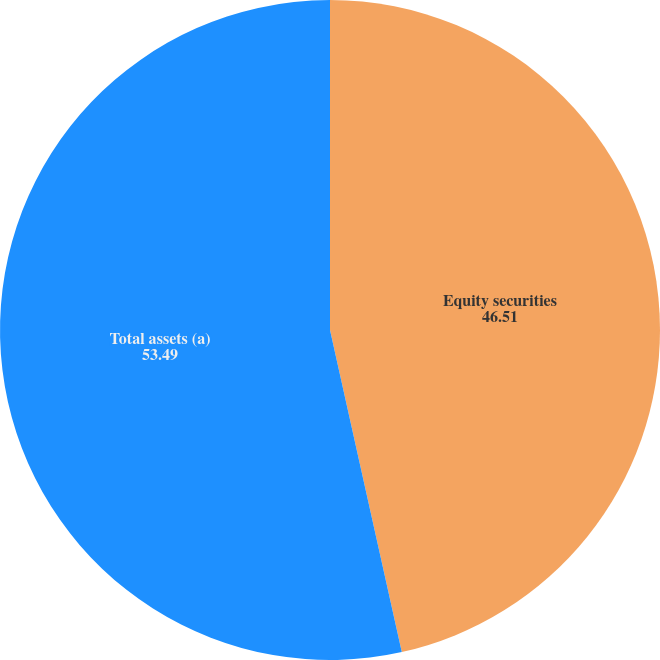Convert chart. <chart><loc_0><loc_0><loc_500><loc_500><pie_chart><fcel>Equity securities<fcel>Total assets (a)<nl><fcel>46.51%<fcel>53.49%<nl></chart> 